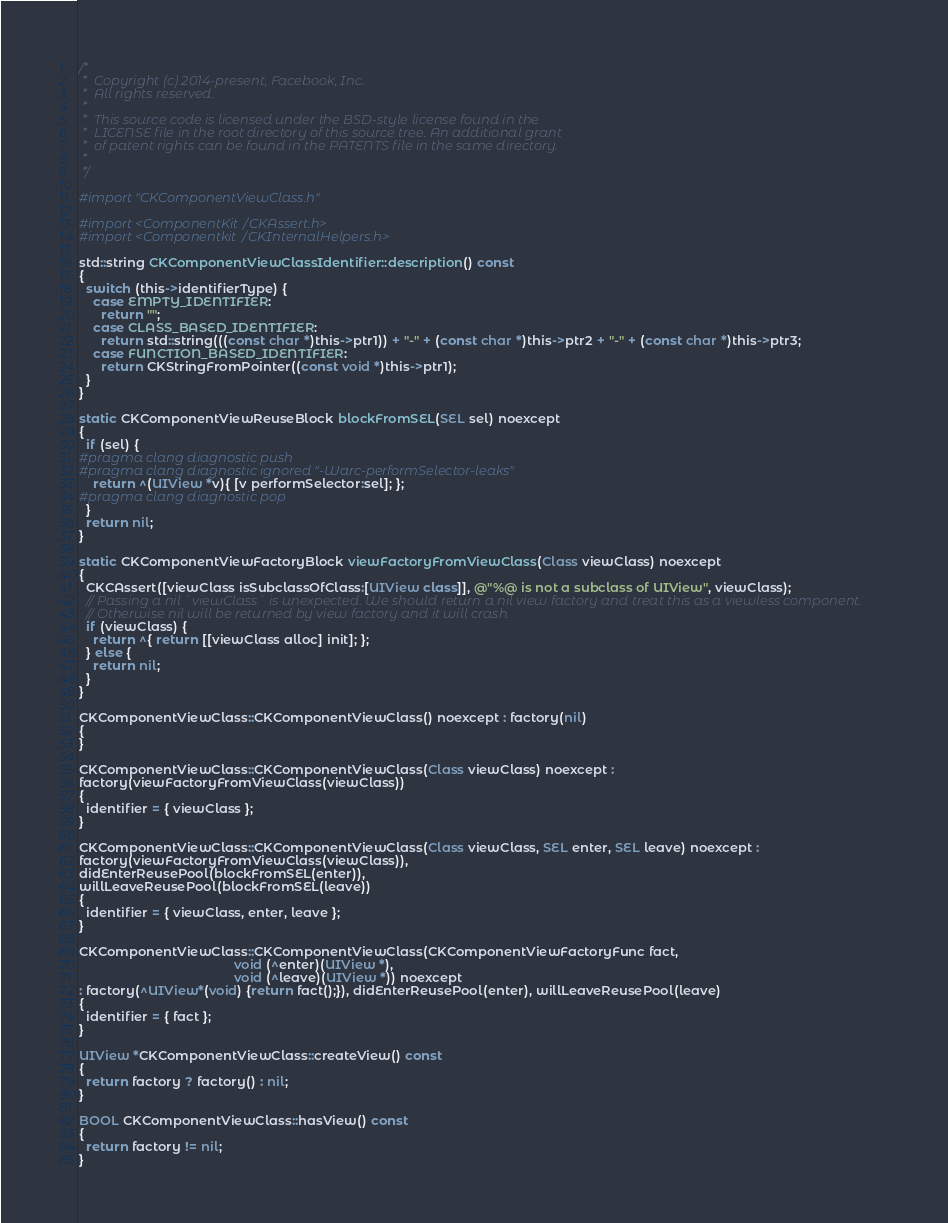<code> <loc_0><loc_0><loc_500><loc_500><_ObjectiveC_>/*
 *  Copyright (c) 2014-present, Facebook, Inc.
 *  All rights reserved.
 *
 *  This source code is licensed under the BSD-style license found in the
 *  LICENSE file in the root directory of this source tree. An additional grant
 *  of patent rights can be found in the PATENTS file in the same directory.
 *
 */

#import "CKComponentViewClass.h"

#import <ComponentKit/CKAssert.h>
#import <Componentkit/CKInternalHelpers.h>

std::string CKComponentViewClassIdentifier::description() const
{
  switch (this->identifierType) {
    case EMPTY_IDENTIFIER:
      return "";
    case CLASS_BASED_IDENTIFIER:
      return std::string(((const char *)this->ptr1)) + "-" + (const char *)this->ptr2 + "-" + (const char *)this->ptr3;
    case FUNCTION_BASED_IDENTIFIER:
      return CKStringFromPointer((const void *)this->ptr1);
  }
}

static CKComponentViewReuseBlock blockFromSEL(SEL sel) noexcept
{
  if (sel) {
#pragma clang diagnostic push
#pragma clang diagnostic ignored "-Warc-performSelector-leaks"
    return ^(UIView *v){ [v performSelector:sel]; };
#pragma clang diagnostic pop
  }
  return nil;
}

static CKComponentViewFactoryBlock viewFactoryFromViewClass(Class viewClass) noexcept
{
  CKCAssert([viewClass isSubclassOfClass:[UIView class]], @"%@ is not a subclass of UIView", viewClass);
  // Passing a nil `viewClass` is unexpected. We should return a nil view factory and treat this as a viewless component.
  // Otherwise nil will be returned by view factory and it will crash.
  if (viewClass) {
    return ^{ return [[viewClass alloc] init]; };
  } else {
    return nil;
  }
}

CKComponentViewClass::CKComponentViewClass() noexcept : factory(nil)
{
}

CKComponentViewClass::CKComponentViewClass(Class viewClass) noexcept :
factory(viewFactoryFromViewClass(viewClass))
{
  identifier = { viewClass };
}

CKComponentViewClass::CKComponentViewClass(Class viewClass, SEL enter, SEL leave) noexcept :
factory(viewFactoryFromViewClass(viewClass)),
didEnterReusePool(blockFromSEL(enter)),
willLeaveReusePool(blockFromSEL(leave))
{
  identifier = { viewClass, enter, leave };
}

CKComponentViewClass::CKComponentViewClass(CKComponentViewFactoryFunc fact,
                                           void (^enter)(UIView *),
                                           void (^leave)(UIView *)) noexcept
: factory(^UIView*(void) {return fact();}), didEnterReusePool(enter), willLeaveReusePool(leave)
{
  identifier = { fact };
}

UIView *CKComponentViewClass::createView() const
{
  return factory ? factory() : nil;
}

BOOL CKComponentViewClass::hasView() const
{
  return factory != nil;
}
</code> 